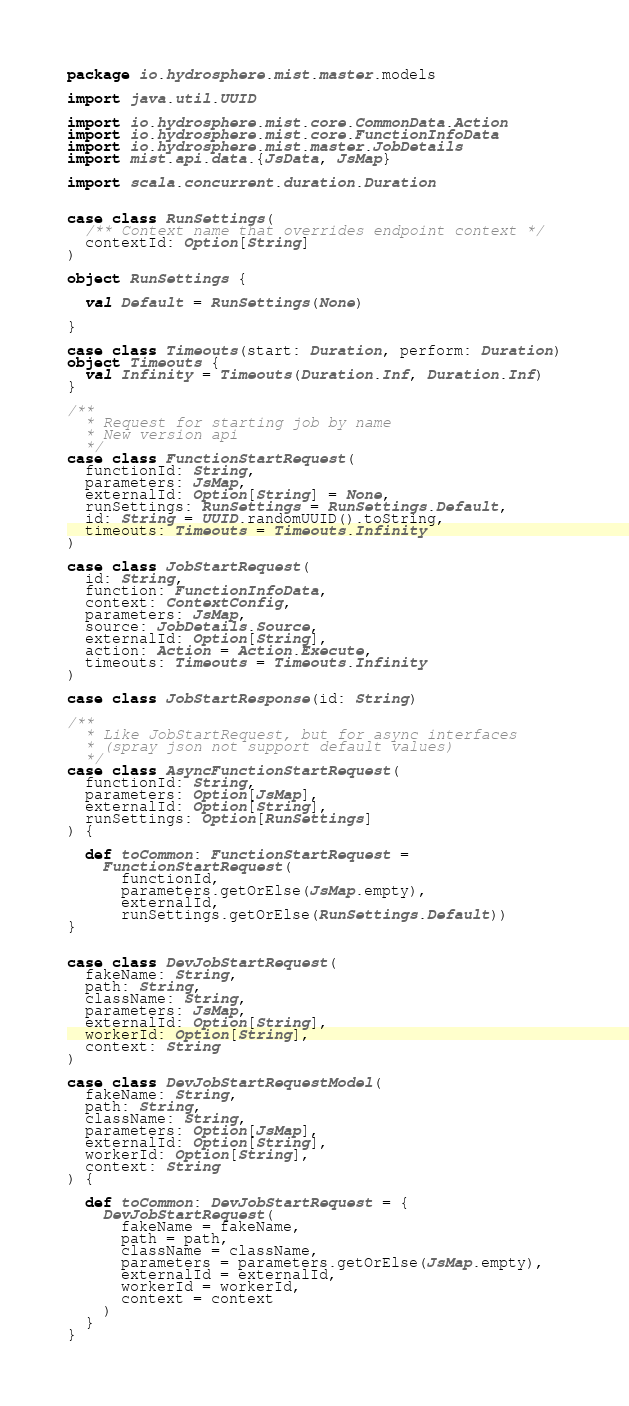<code> <loc_0><loc_0><loc_500><loc_500><_Scala_>package io.hydrosphere.mist.master.models

import java.util.UUID

import io.hydrosphere.mist.core.CommonData.Action
import io.hydrosphere.mist.core.FunctionInfoData
import io.hydrosphere.mist.master.JobDetails
import mist.api.data.{JsData, JsMap}

import scala.concurrent.duration.Duration


case class RunSettings(
  /** Context name that overrides endpoint context */
  contextId: Option[String]
)

object RunSettings {

  val Default = RunSettings(None)

}

case class Timeouts(start: Duration, perform: Duration)
object Timeouts {
  val Infinity = Timeouts(Duration.Inf, Duration.Inf)
}

/**
  * Request for starting job by name
  * New version api
  */
case class FunctionStartRequest(
  functionId: String,
  parameters: JsMap,
  externalId: Option[String] = None,
  runSettings: RunSettings = RunSettings.Default,
  id: String = UUID.randomUUID().toString,
  timeouts: Timeouts = Timeouts.Infinity
)

case class JobStartRequest(
  id: String,
  function: FunctionInfoData,
  context: ContextConfig,
  parameters: JsMap,
  source: JobDetails.Source,
  externalId: Option[String],
  action: Action = Action.Execute,
  timeouts: Timeouts = Timeouts.Infinity
)

case class JobStartResponse(id: String)

/**
  * Like JobStartRequest, but for async interfaces
  * (spray json not support default values)
  */
case class AsyncFunctionStartRequest(
  functionId: String,
  parameters: Option[JsMap],
  externalId: Option[String],
  runSettings: Option[RunSettings]
) {

  def toCommon: FunctionStartRequest =
    FunctionStartRequest(
      functionId,
      parameters.getOrElse(JsMap.empty),
      externalId,
      runSettings.getOrElse(RunSettings.Default))
}


case class DevJobStartRequest(
  fakeName: String,
  path: String,
  className: String,
  parameters: JsMap,
  externalId: Option[String],
  workerId: Option[String],
  context: String
)

case class DevJobStartRequestModel(
  fakeName: String,
  path: String,
  className: String,
  parameters: Option[JsMap],
  externalId: Option[String],
  workerId: Option[String],
  context: String
) {

  def toCommon: DevJobStartRequest = {
    DevJobStartRequest(
      fakeName = fakeName,
      path = path,
      className = className,
      parameters = parameters.getOrElse(JsMap.empty),
      externalId = externalId,
      workerId = workerId,
      context = context
    )
  }
}
</code> 